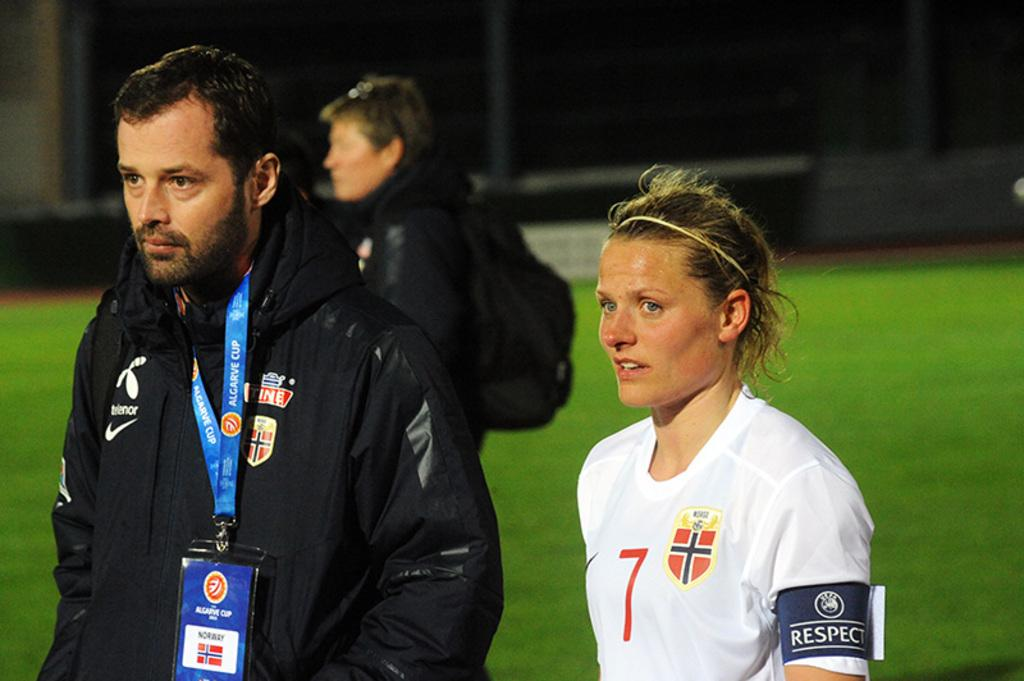<image>
Write a terse but informative summary of the picture. A man walks next to a woman who wears an armband saying Respect 